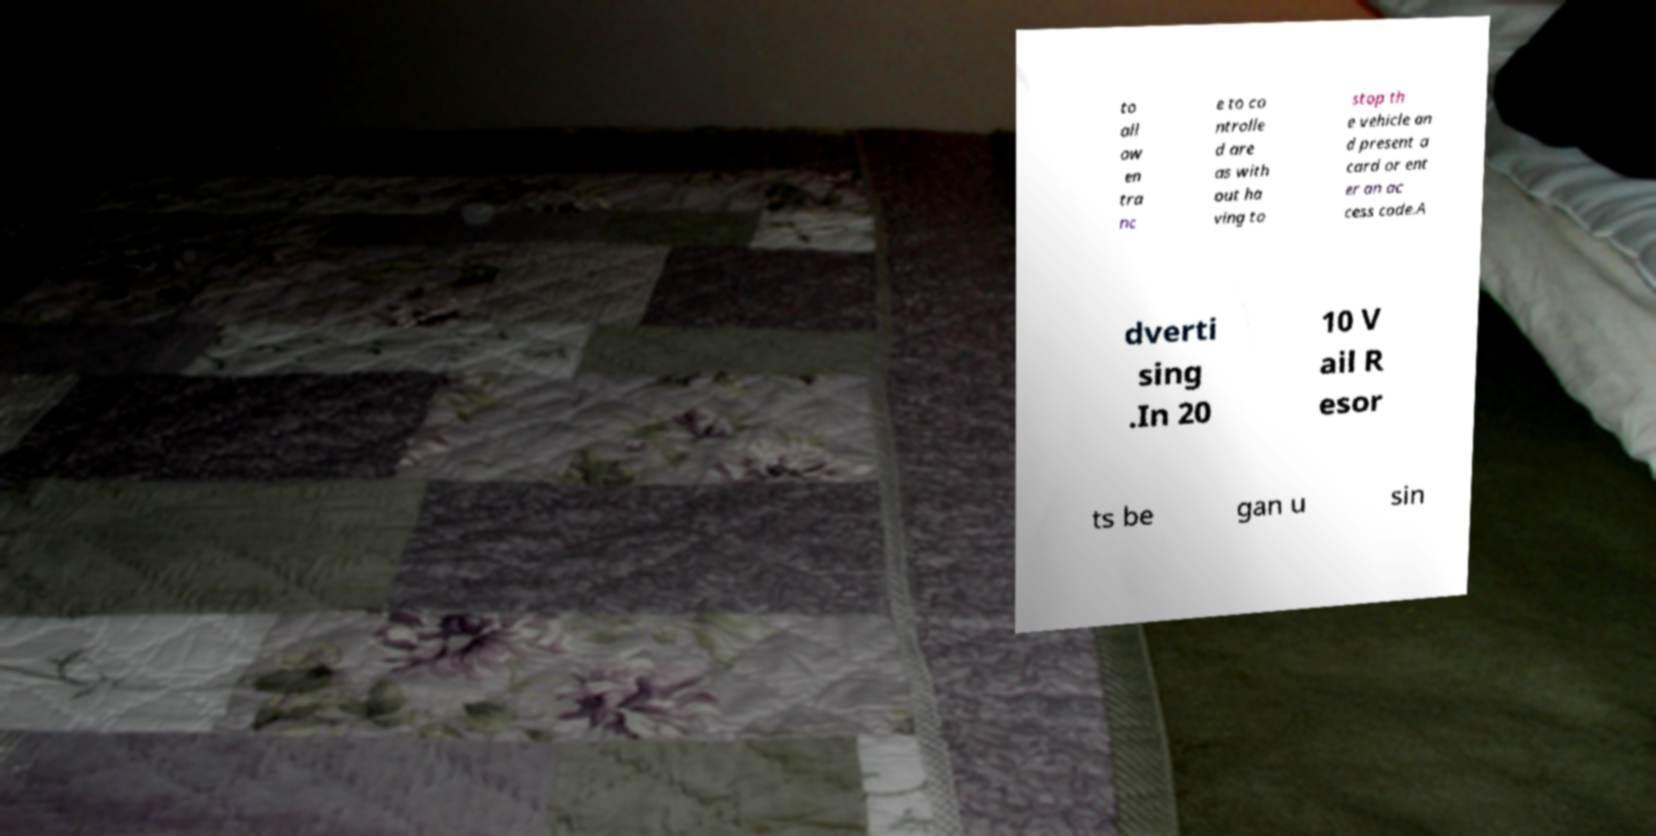Please identify and transcribe the text found in this image. to all ow en tra nc e to co ntrolle d are as with out ha ving to stop th e vehicle an d present a card or ent er an ac cess code.A dverti sing .In 20 10 V ail R esor ts be gan u sin 